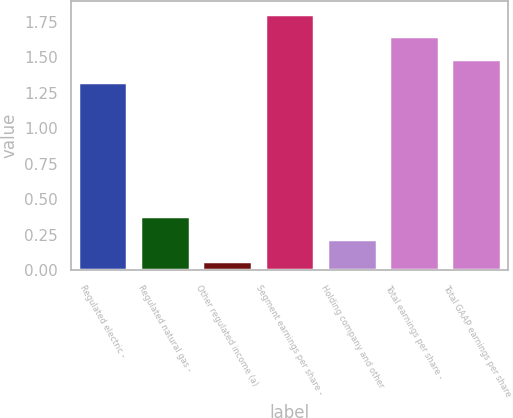Convert chart to OTSL. <chart><loc_0><loc_0><loc_500><loc_500><bar_chart><fcel>Regulated electric -<fcel>Regulated natural gas -<fcel>Other regulated income (a)<fcel>Segment earnings per share -<fcel>Holding company and other<fcel>Total earnings per share -<fcel>Total GAAP earnings per share<nl><fcel>1.33<fcel>0.38<fcel>0.06<fcel>1.81<fcel>0.22<fcel>1.65<fcel>1.49<nl></chart> 